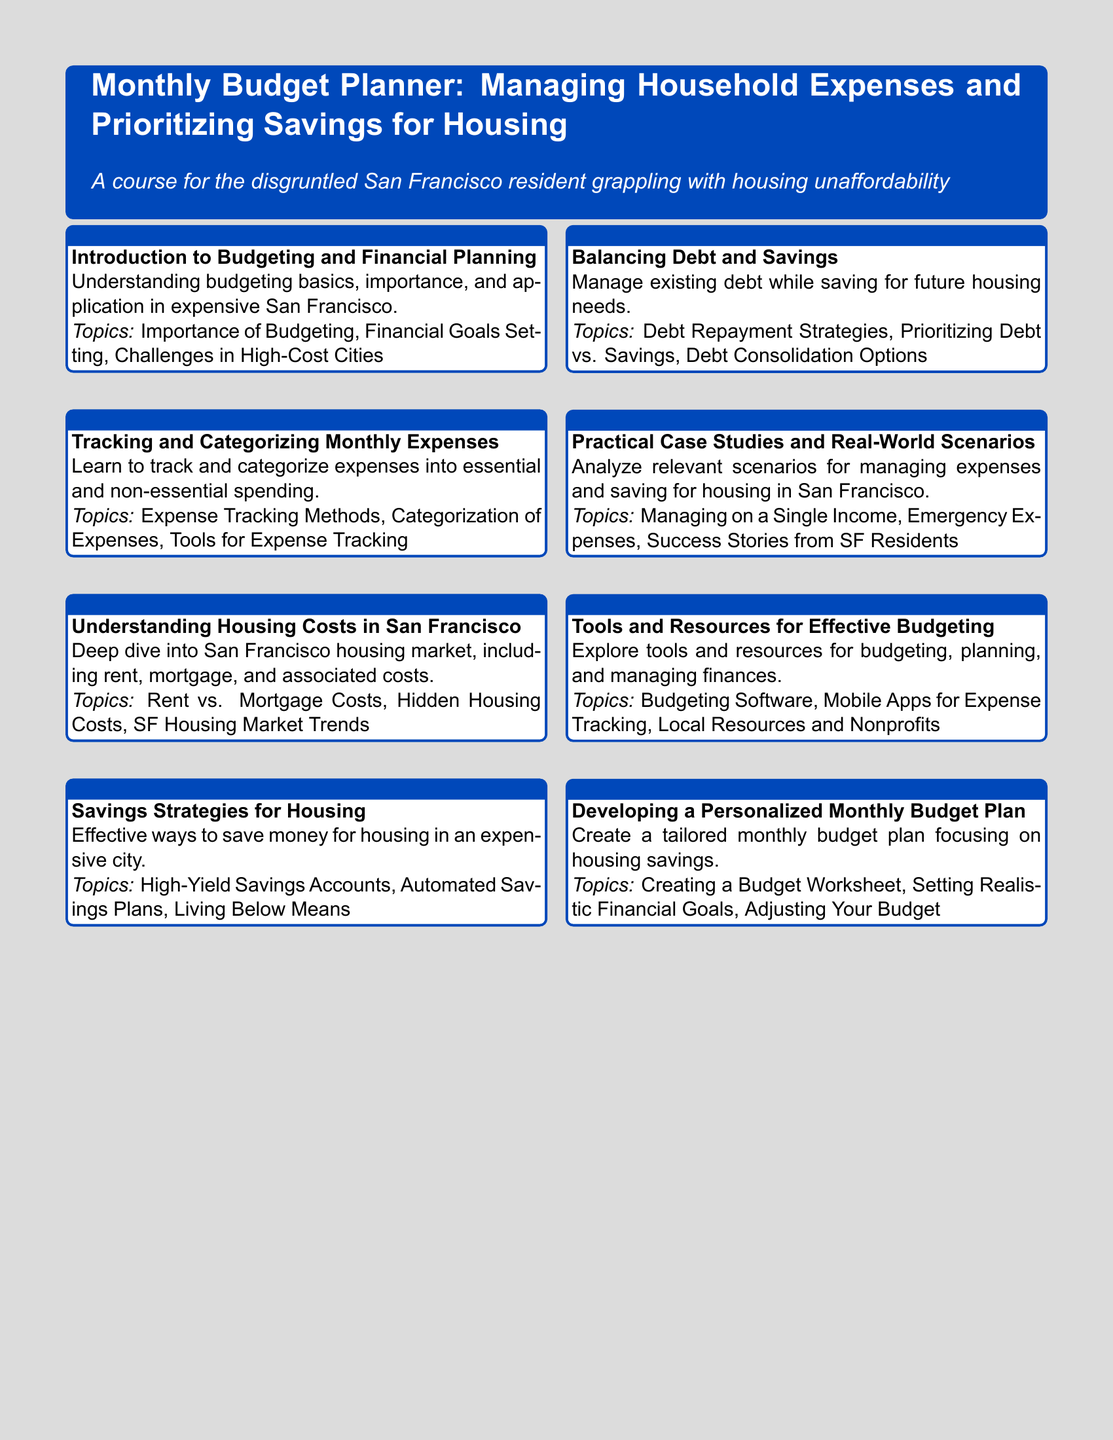what is the title of the course? The title of the course is found in the header section of the syllabus.
Answer: Monthly Budget Planner: Managing Household Expenses and Prioritizing Savings for Housing how many modules are included in the syllabus? The number of modules can be counted in the list provided in the document.
Answer: 8 what is the focus of Module 3? The focus of Module 3 is described in the module summary section.
Answer: Understanding Housing Costs in San Francisco what strategy is discussed in Module 4? Module 4 highlights a particular approach to managing finances, found in its topics.
Answer: Savings Strategies for Housing what tools are mentioned in Module 7? The tools discussed in Module 7 relate to budgeting and finance.
Answer: Budgeting Software, Mobile Apps for Expense Tracking, Local Resources and Nonprofits which module addresses case studies? The module that analyzes real-life scenarios is identified in the topics.
Answer: Module 6 what financial challenge is highlighted in Module 5? The specific financial challenge discussed in Module 5 can be found in its topics.
Answer: Balancing Debt and Savings what is the primary outcome of Module 8? The expected outcome of Module 8 relates to creating a personalized plan, stated in its summary.
Answer: Developing a Personalized Monthly Budget Plan 